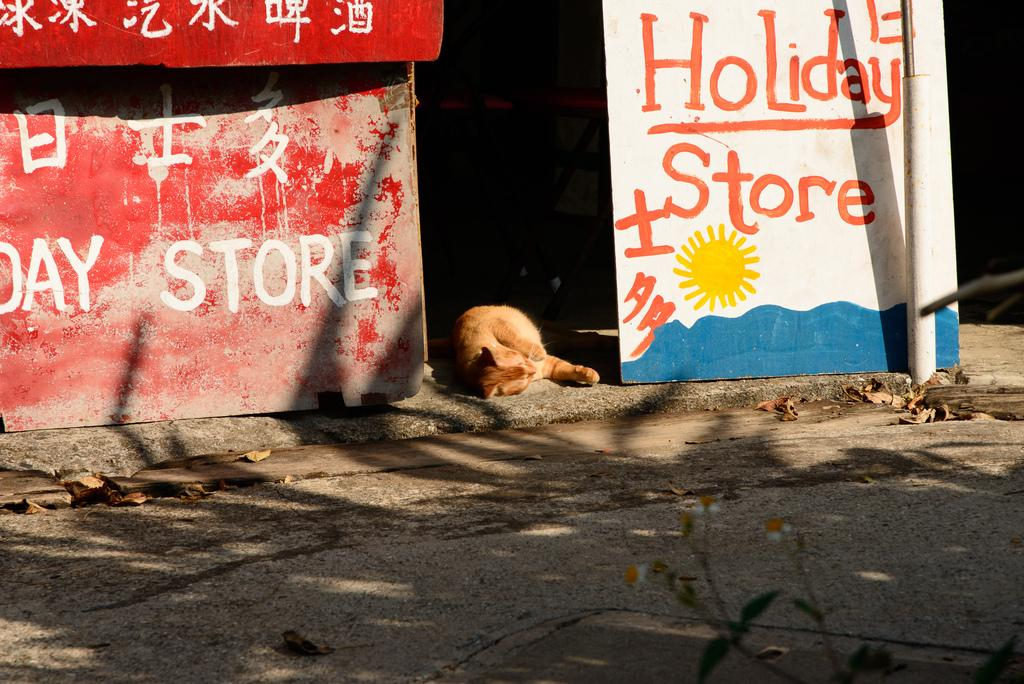What is displayed on the hoarding in the image? There is a hoarding with text in the image. What animal can be seen in the image? A cat is sleeping on a surface in the image. What type of natural debris is present on the road in the image? Dried leaves are on the road at the bottom of the image. What type of paper is the cat using to cover itself in the image? There is no paper present in the image, and the cat is not using any paper to cover itself. Can you see the cat's self in the image? The term "self" refers to a person's identity or individuality, and it is not applicable to the cat in the image. The cat is simply sleeping on a surface. 